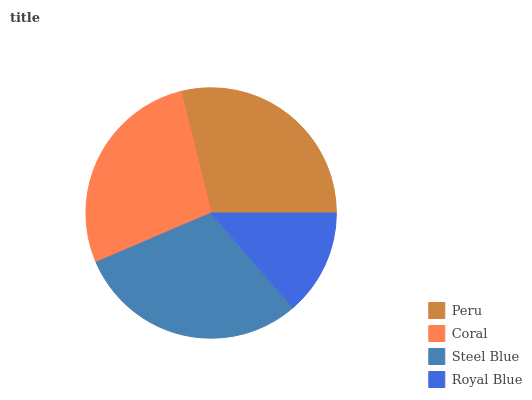Is Royal Blue the minimum?
Answer yes or no. Yes. Is Steel Blue the maximum?
Answer yes or no. Yes. Is Coral the minimum?
Answer yes or no. No. Is Coral the maximum?
Answer yes or no. No. Is Peru greater than Coral?
Answer yes or no. Yes. Is Coral less than Peru?
Answer yes or no. Yes. Is Coral greater than Peru?
Answer yes or no. No. Is Peru less than Coral?
Answer yes or no. No. Is Peru the high median?
Answer yes or no. Yes. Is Coral the low median?
Answer yes or no. Yes. Is Steel Blue the high median?
Answer yes or no. No. Is Steel Blue the low median?
Answer yes or no. No. 